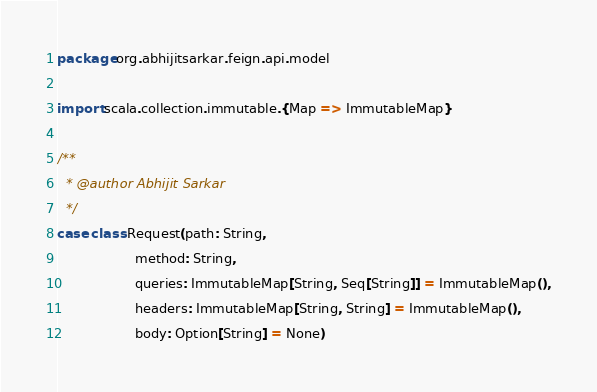Convert code to text. <code><loc_0><loc_0><loc_500><loc_500><_Scala_>package org.abhijitsarkar.feign.api.model

import scala.collection.immutable.{Map => ImmutableMap}

/**
  * @author Abhijit Sarkar
  */
case class Request(path: String,
                   method: String,
                   queries: ImmutableMap[String, Seq[String]] = ImmutableMap(),
                   headers: ImmutableMap[String, String] = ImmutableMap(),
                   body: Option[String] = None)

</code> 